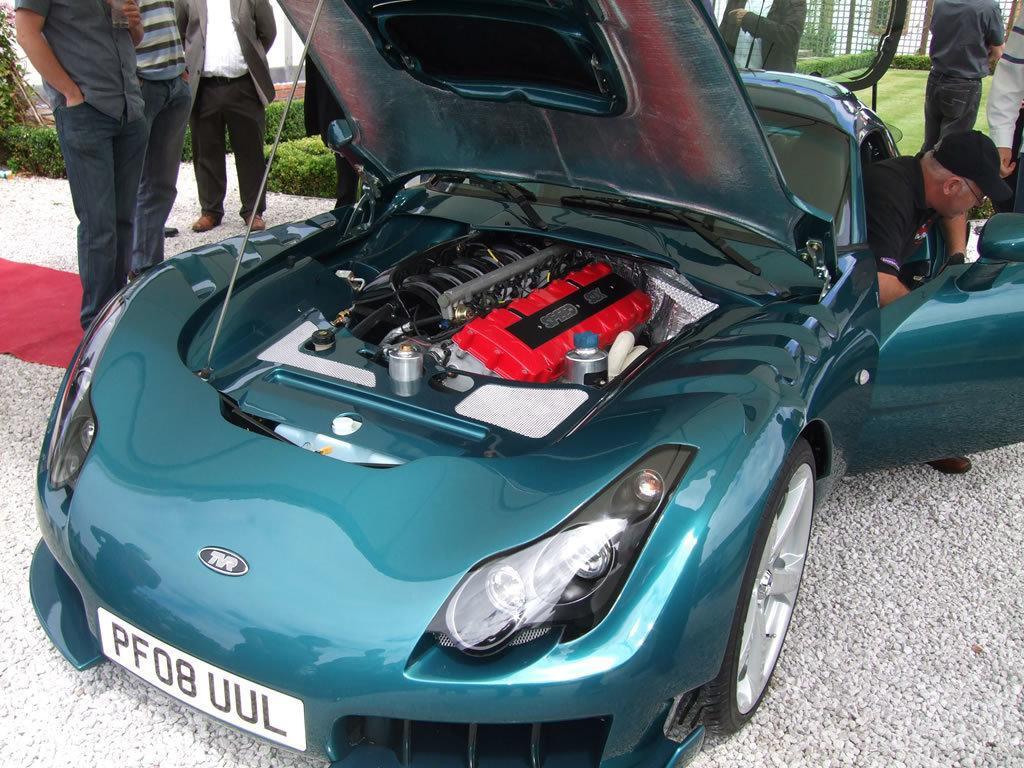What color is the car in the image? The car in the image is green. What can be seen around the car in the image? There are people around the car in the image. How many ladybugs are crawling on the car in the image? There are no ladybugs visible on the car in the image. What activity are the people around the car participating in? The facts provided do not specify any particular activity the people around the car are participating in. 